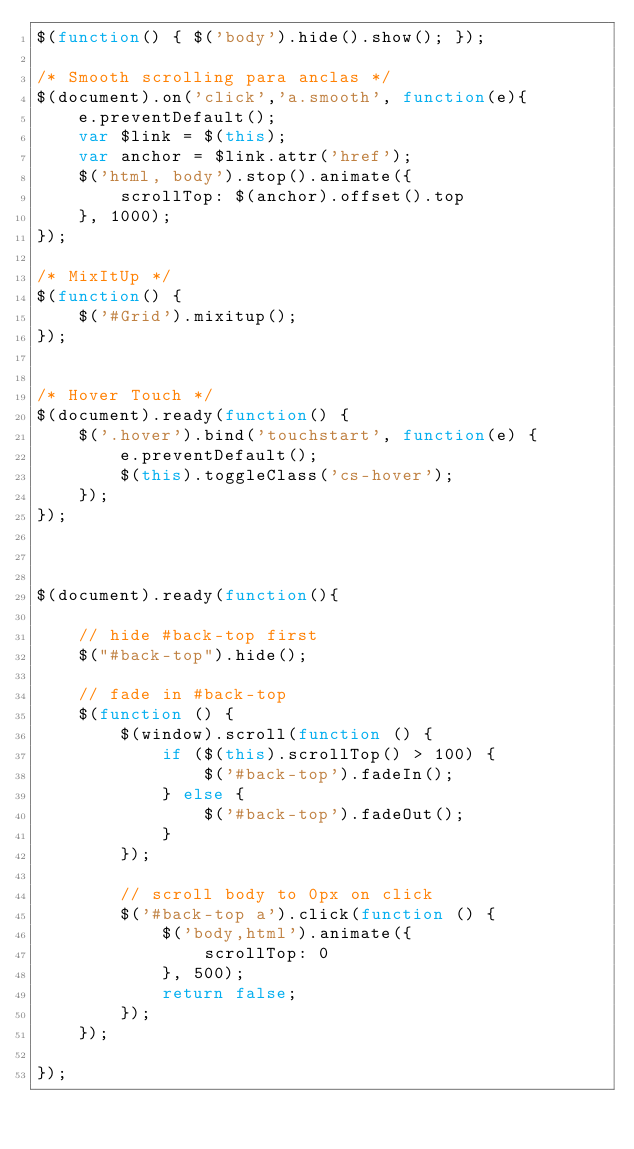<code> <loc_0><loc_0><loc_500><loc_500><_JavaScript_>$(function() { $('body').hide().show(); });

/* Smooth scrolling para anclas */  
$(document).on('click','a.smooth', function(e){
    e.preventDefault();
    var $link = $(this);
    var anchor = $link.attr('href');
    $('html, body').stop().animate({
        scrollTop: $(anchor).offset().top
    }, 1000);
});

/* MixItUp */
$(function() {
    $('#Grid').mixitup();
});


/* Hover Touch */
$(document).ready(function() {
    $('.hover').bind('touchstart', function(e) {
        e.preventDefault();
        $(this).toggleClass('cs-hover');
    });
});



$(document).ready(function(){

    // hide #back-top first
    $("#back-top").hide();
    
    // fade in #back-top
    $(function () {
        $(window).scroll(function () {
            if ($(this).scrollTop() > 100) {
                $('#back-top').fadeIn();
            } else {
                $('#back-top').fadeOut();
            }
        });

        // scroll body to 0px on click
        $('#back-top a').click(function () {
            $('body,html').animate({
                scrollTop: 0
            }, 500);
            return false;
        });
    });

});
</code> 